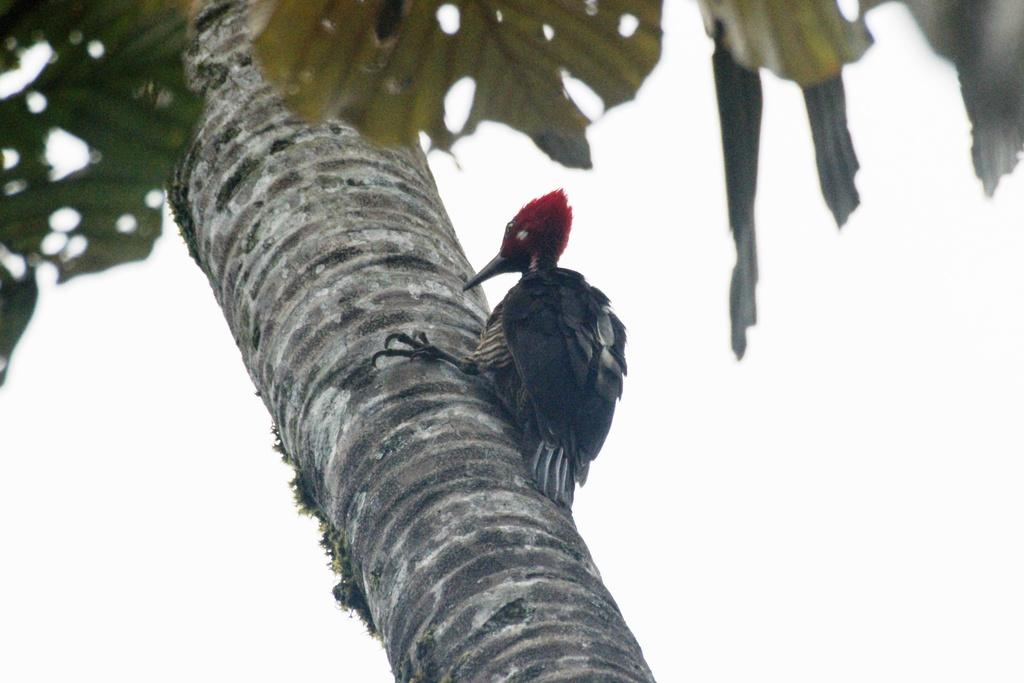Where was the image taken? The image was taken outdoors. What can be seen in the background of the image? The sky is visible in the background of the image. What is located in the middle of the image? There is a tree in the middle of the image. What is on the tree in the image? There is a bird on the tree. What type of stew is being prepared in the image? There is no stew present in the image; it features a tree with a bird on it. Can you see any other animals joining the bird on the tree? There are no other animals visible in the image, only the bird on the tree. 